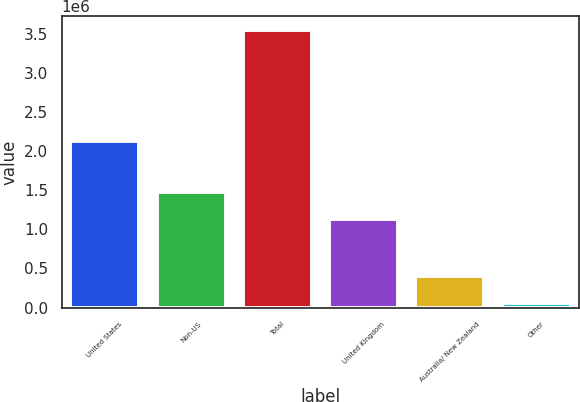Convert chart to OTSL. <chart><loc_0><loc_0><loc_500><loc_500><bar_chart><fcel>United States<fcel>Non-US<fcel>Total<fcel>United Kingdom<fcel>Australia/ New Zealand<fcel>Other<nl><fcel>2.13236e+06<fcel>1.47788e+06<fcel>3.55243e+06<fcel>1.12802e+06<fcel>403682<fcel>53821<nl></chart> 